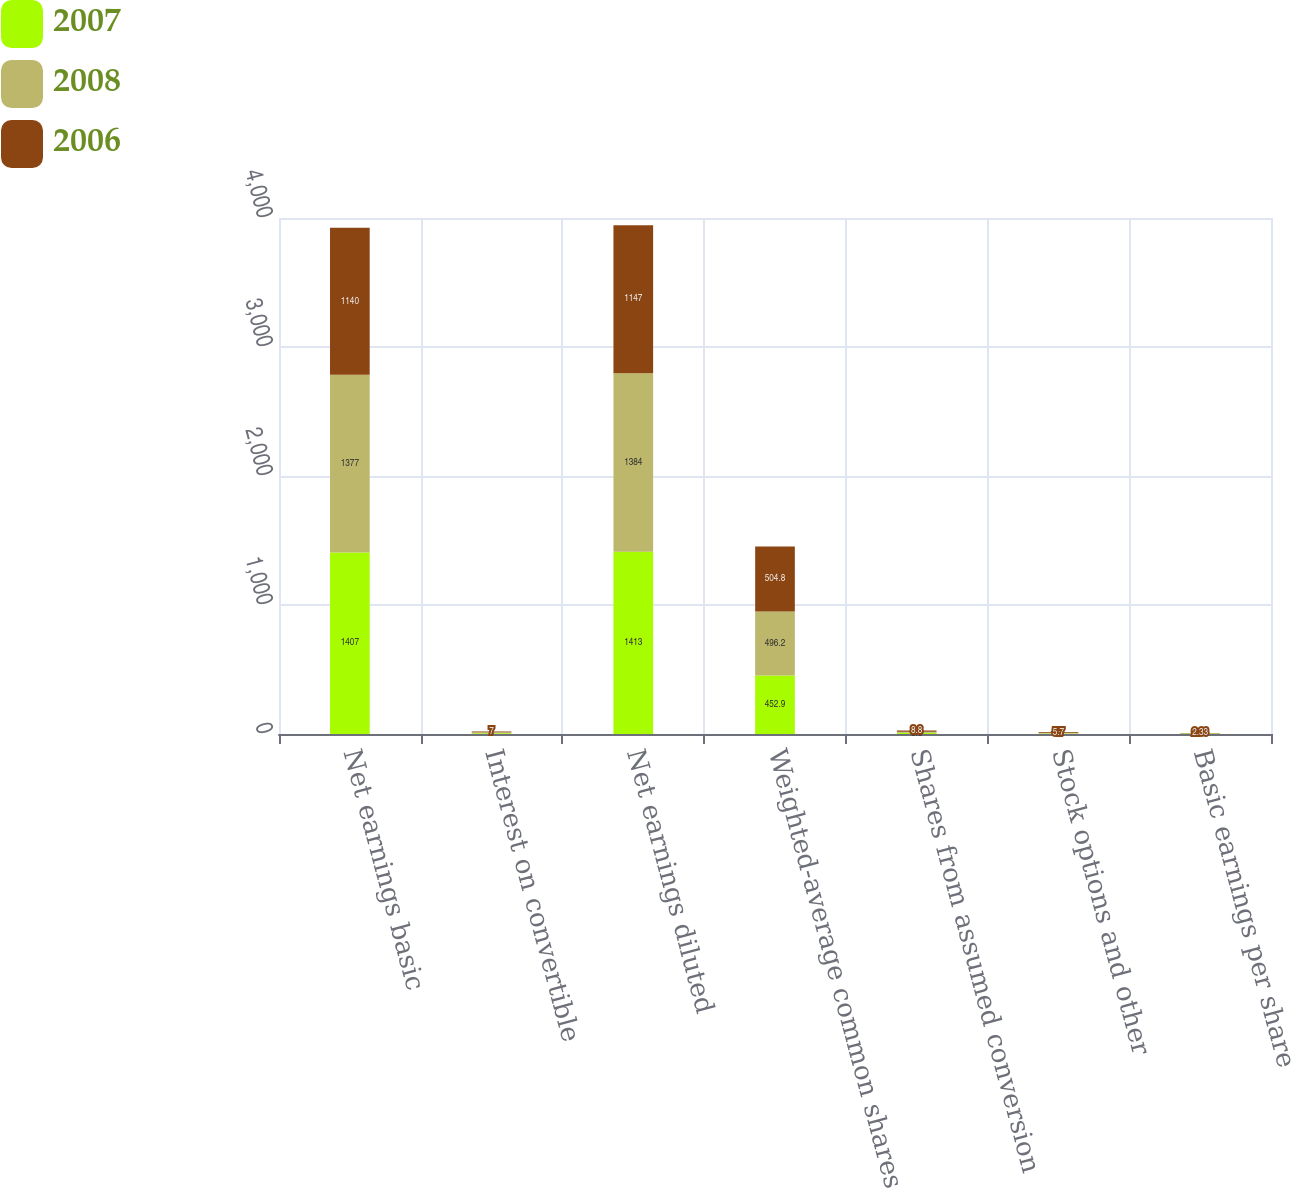Convert chart to OTSL. <chart><loc_0><loc_0><loc_500><loc_500><stacked_bar_chart><ecel><fcel>Net earnings basic<fcel>Interest on convertible<fcel>Net earnings diluted<fcel>Weighted-average common shares<fcel>Shares from assumed conversion<fcel>Stock options and other<fcel>Basic earnings per share<nl><fcel>2007<fcel>1407<fcel>6<fcel>1413<fcel>452.9<fcel>8.8<fcel>4.2<fcel>3.2<nl><fcel>2008<fcel>1377<fcel>7<fcel>1384<fcel>496.2<fcel>8.8<fcel>5.3<fcel>2.86<nl><fcel>2006<fcel>1140<fcel>7<fcel>1147<fcel>504.8<fcel>8.8<fcel>5.7<fcel>2.33<nl></chart> 